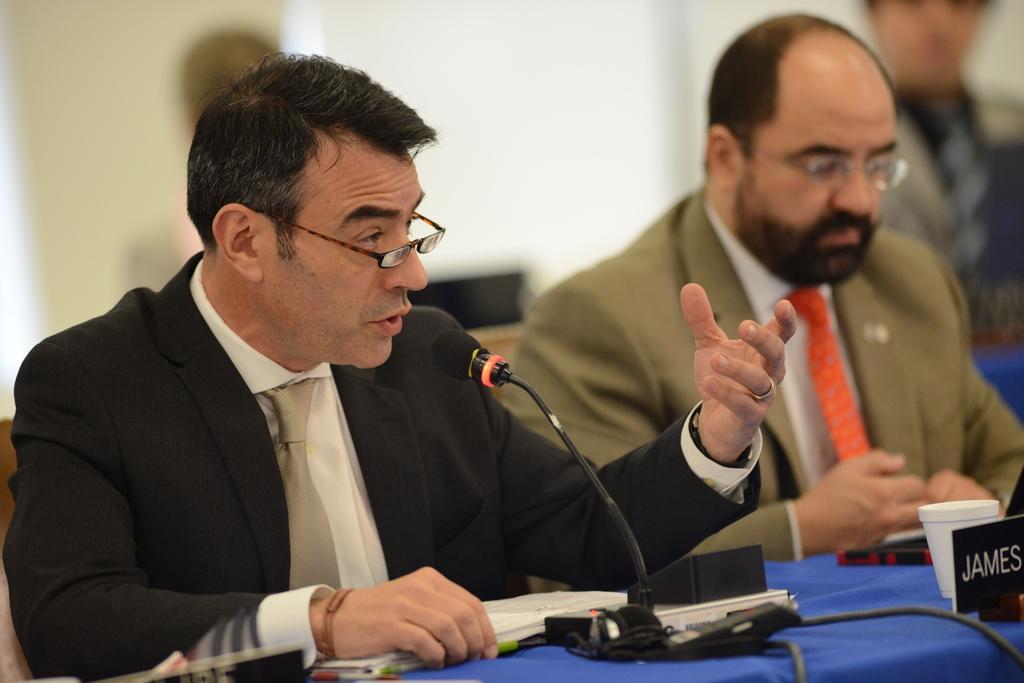In one or two sentences, can you explain what this image depicts? Background portion of the picture is blurry. On the right side of the picture a person is visible. In this picture we can see men wearing spectacles. On a table we can see name board, microphone, glass, pen and objects. On the left side of the picture we can see a man is talking. 